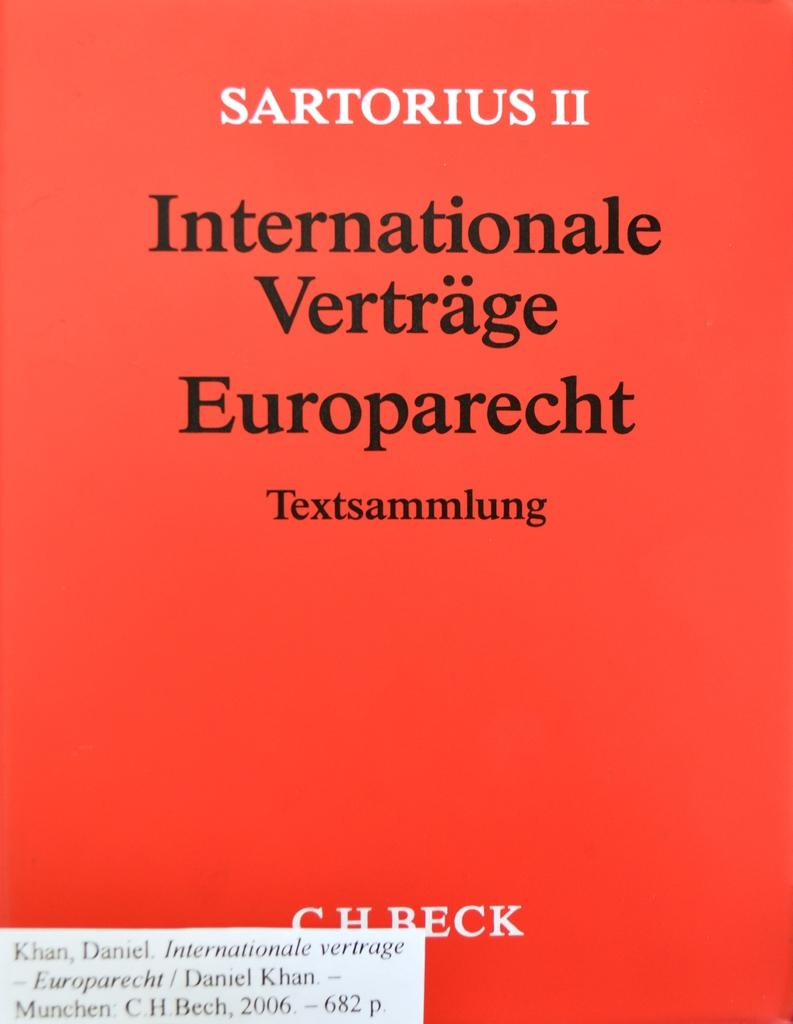<image>
Present a compact description of the photo's key features. A cover lists the author as C.H. Beck and is red in color. 